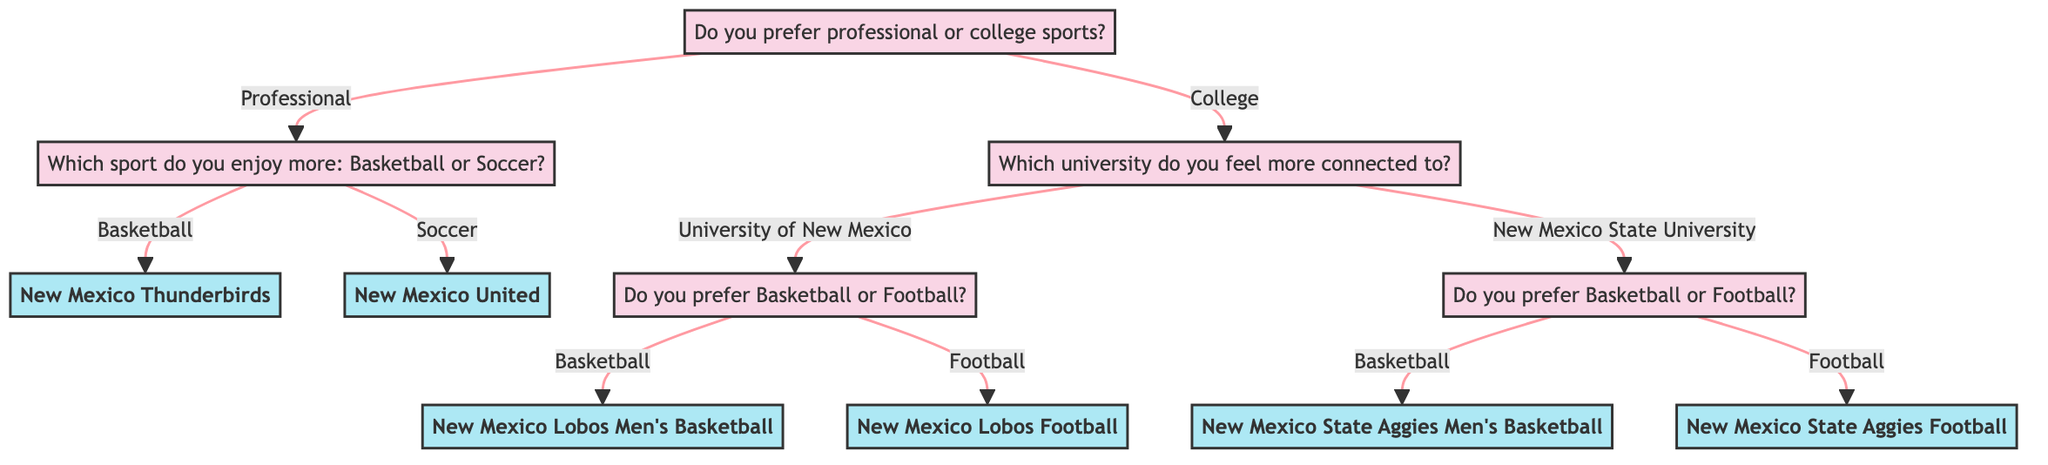What is the first question in the decision tree? The first question is at the root of the diagram, which asks whether the person prefers professional or college sports.
Answer: Do you prefer professional or college sports? Which team is selected if a person prefers professional sports and enjoys basketball? Following the decision path of preferring professional sports, the next question asks about the sport, which leads to the New Mexico Thunderbirds if basketball is chosen.
Answer: New Mexico Thunderbirds How many teams are listed in the diagram? The diagram includes six teams: New Mexico Thunderbirds, New Mexico United, New Mexico Lobos Men's Basketball, New Mexico Lobos Football, New Mexico State Aggies Men's Basketball, and New Mexico State Aggies Football. Counting all teams gives a total of six.
Answer: 6 If someone prefers college sports and chose New Mexico State University, which team will they end up supporting if they enjoy football? After selecting college sports and New Mexico State University, the next question pertains to the preference for basketball or football. Selecting football leads to supporting New Mexico State Aggies Football.
Answer: New Mexico State Aggies Football What is the relationship between "University of New Mexico" and "New Mexico Lobos Men's Basketball"? The University of New Mexico is a branch in the decision tree for college sports. If a person indicates a preference for this university and chooses basketball, they will end up at New Mexico Lobos Men's Basketball.
Answer: University of New Mexico → New Mexico Lobos Men's Basketball What question follows after selecting "New Mexico United"? If a person selects New Mexico United, which is the outcome of preferring professional sports and soccer, there are no further questions; therefore, this is the final answer with no additional branching.
Answer: (No further question) Which sport does the decision tree ask about if you chose "University of New Mexico"? After choosing the University of New Mexico under the college sports section, the subsequent question asks whether the person prefers basketball or football.
Answer: Do you prefer Basketball or Football? What is the team name if the answer to the last question is "Football" under New Mexico State University? If the answer to the preference question is football after selecting New Mexico State University, the team identified in the diagram is New Mexico State Aggies Football.
Answer: New Mexico State Aggies Football 